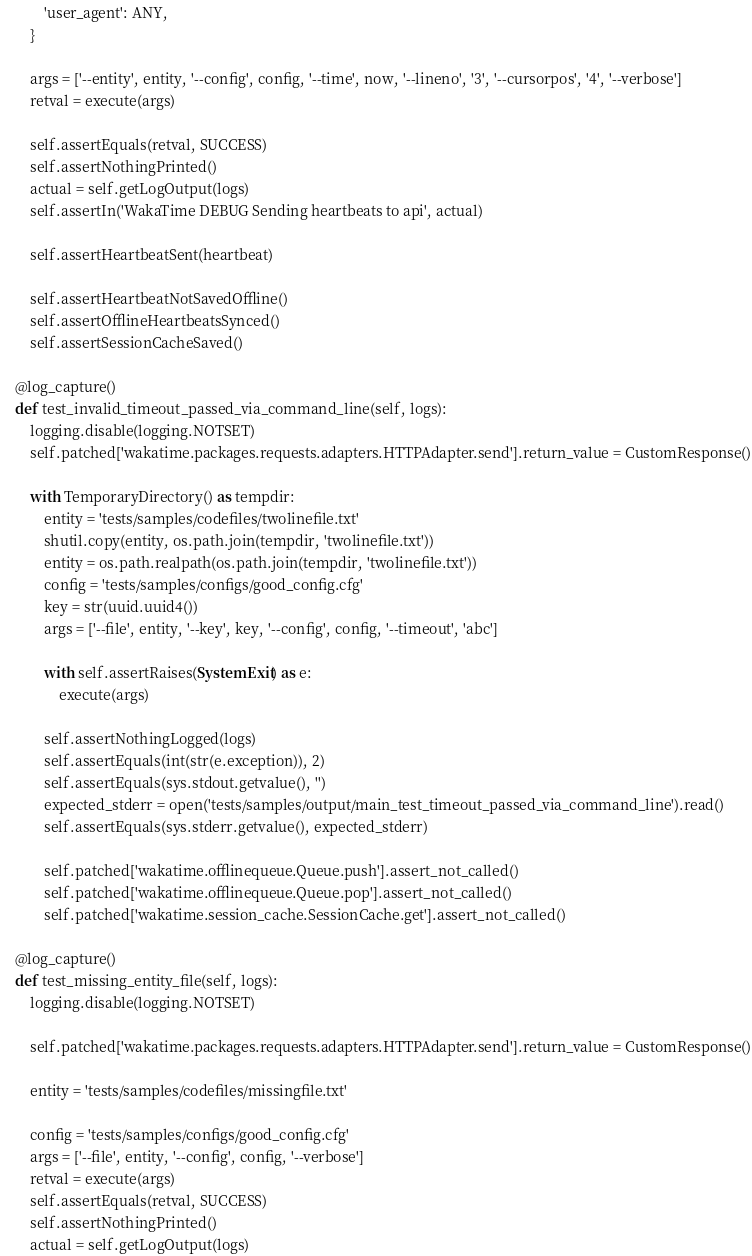Convert code to text. <code><loc_0><loc_0><loc_500><loc_500><_Python_>            'user_agent': ANY,
        }

        args = ['--entity', entity, '--config', config, '--time', now, '--lineno', '3', '--cursorpos', '4', '--verbose']
        retval = execute(args)

        self.assertEquals(retval, SUCCESS)
        self.assertNothingPrinted()
        actual = self.getLogOutput(logs)
        self.assertIn('WakaTime DEBUG Sending heartbeats to api', actual)

        self.assertHeartbeatSent(heartbeat)

        self.assertHeartbeatNotSavedOffline()
        self.assertOfflineHeartbeatsSynced()
        self.assertSessionCacheSaved()

    @log_capture()
    def test_invalid_timeout_passed_via_command_line(self, logs):
        logging.disable(logging.NOTSET)
        self.patched['wakatime.packages.requests.adapters.HTTPAdapter.send'].return_value = CustomResponse()

        with TemporaryDirectory() as tempdir:
            entity = 'tests/samples/codefiles/twolinefile.txt'
            shutil.copy(entity, os.path.join(tempdir, 'twolinefile.txt'))
            entity = os.path.realpath(os.path.join(tempdir, 'twolinefile.txt'))
            config = 'tests/samples/configs/good_config.cfg'
            key = str(uuid.uuid4())
            args = ['--file', entity, '--key', key, '--config', config, '--timeout', 'abc']

            with self.assertRaises(SystemExit) as e:
                execute(args)

            self.assertNothingLogged(logs)
            self.assertEquals(int(str(e.exception)), 2)
            self.assertEquals(sys.stdout.getvalue(), '')
            expected_stderr = open('tests/samples/output/main_test_timeout_passed_via_command_line').read()
            self.assertEquals(sys.stderr.getvalue(), expected_stderr)

            self.patched['wakatime.offlinequeue.Queue.push'].assert_not_called()
            self.patched['wakatime.offlinequeue.Queue.pop'].assert_not_called()
            self.patched['wakatime.session_cache.SessionCache.get'].assert_not_called()

    @log_capture()
    def test_missing_entity_file(self, logs):
        logging.disable(logging.NOTSET)

        self.patched['wakatime.packages.requests.adapters.HTTPAdapter.send'].return_value = CustomResponse()

        entity = 'tests/samples/codefiles/missingfile.txt'

        config = 'tests/samples/configs/good_config.cfg'
        args = ['--file', entity, '--config', config, '--verbose']
        retval = execute(args)
        self.assertEquals(retval, SUCCESS)
        self.assertNothingPrinted()
        actual = self.getLogOutput(logs)</code> 